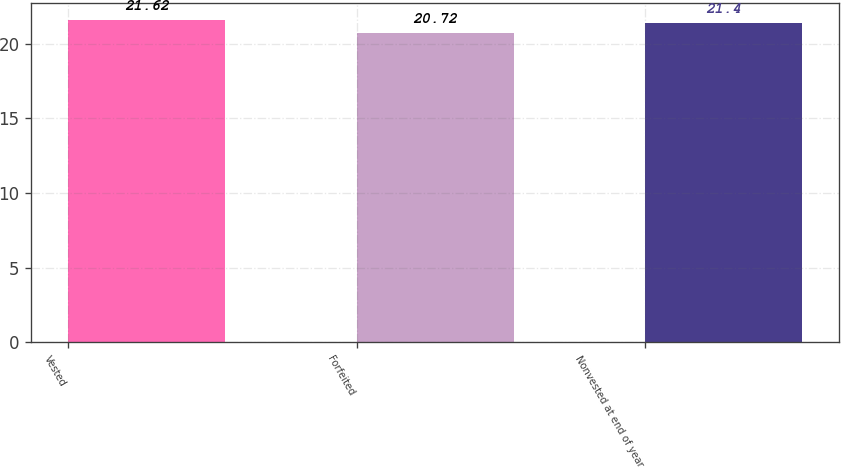Convert chart to OTSL. <chart><loc_0><loc_0><loc_500><loc_500><bar_chart><fcel>Vested<fcel>Forfeited<fcel>Nonvested at end of year<nl><fcel>21.62<fcel>20.72<fcel>21.4<nl></chart> 